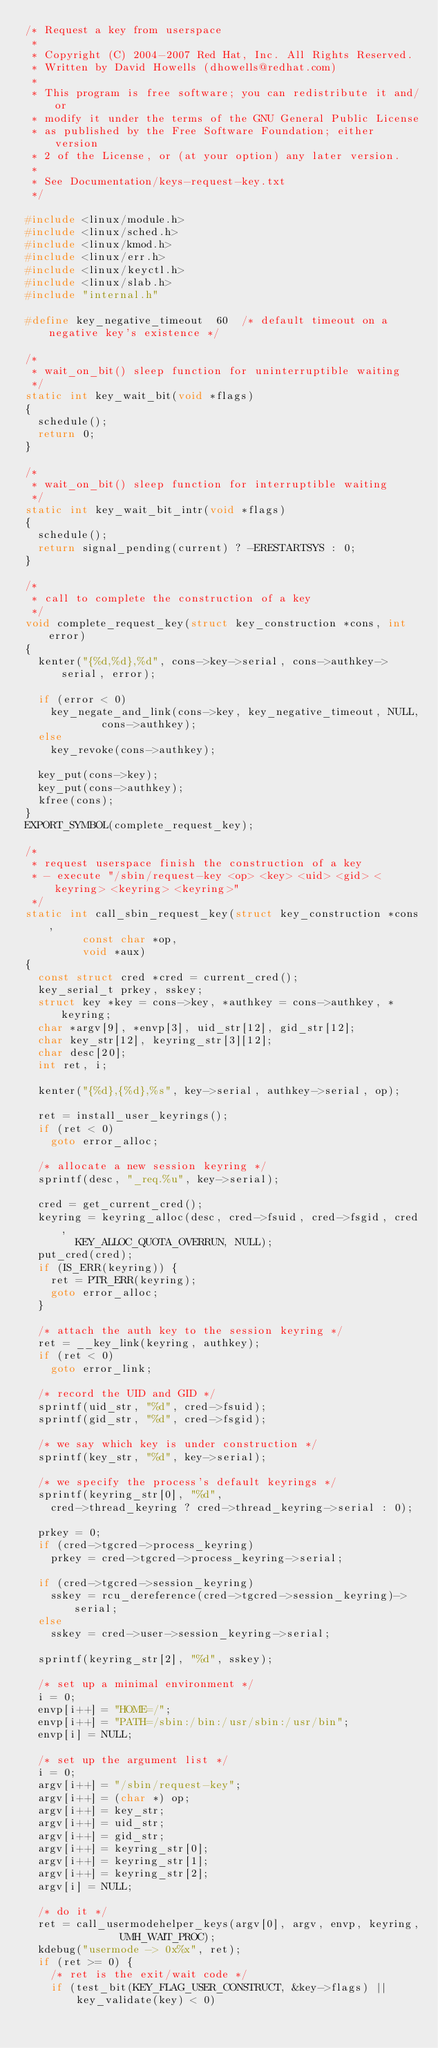Convert code to text. <code><loc_0><loc_0><loc_500><loc_500><_C_>/* Request a key from userspace
 *
 * Copyright (C) 2004-2007 Red Hat, Inc. All Rights Reserved.
 * Written by David Howells (dhowells@redhat.com)
 *
 * This program is free software; you can redistribute it and/or
 * modify it under the terms of the GNU General Public License
 * as published by the Free Software Foundation; either version
 * 2 of the License, or (at your option) any later version.
 *
 * See Documentation/keys-request-key.txt
 */

#include <linux/module.h>
#include <linux/sched.h>
#include <linux/kmod.h>
#include <linux/err.h>
#include <linux/keyctl.h>
#include <linux/slab.h>
#include "internal.h"

#define key_negative_timeout	60	/* default timeout on a negative key's existence */

/*
 * wait_on_bit() sleep function for uninterruptible waiting
 */
static int key_wait_bit(void *flags)
{
	schedule();
	return 0;
}

/*
 * wait_on_bit() sleep function for interruptible waiting
 */
static int key_wait_bit_intr(void *flags)
{
	schedule();
	return signal_pending(current) ? -ERESTARTSYS : 0;
}

/*
 * call to complete the construction of a key
 */
void complete_request_key(struct key_construction *cons, int error)
{
	kenter("{%d,%d},%d", cons->key->serial, cons->authkey->serial, error);

	if (error < 0)
		key_negate_and_link(cons->key, key_negative_timeout, NULL,
				    cons->authkey);
	else
		key_revoke(cons->authkey);

	key_put(cons->key);
	key_put(cons->authkey);
	kfree(cons);
}
EXPORT_SYMBOL(complete_request_key);

/*
 * request userspace finish the construction of a key
 * - execute "/sbin/request-key <op> <key> <uid> <gid> <keyring> <keyring> <keyring>"
 */
static int call_sbin_request_key(struct key_construction *cons,
				 const char *op,
				 void *aux)
{
	const struct cred *cred = current_cred();
	key_serial_t prkey, sskey;
	struct key *key = cons->key, *authkey = cons->authkey, *keyring;
	char *argv[9], *envp[3], uid_str[12], gid_str[12];
	char key_str[12], keyring_str[3][12];
	char desc[20];
	int ret, i;

	kenter("{%d},{%d},%s", key->serial, authkey->serial, op);

	ret = install_user_keyrings();
	if (ret < 0)
		goto error_alloc;

	/* allocate a new session keyring */
	sprintf(desc, "_req.%u", key->serial);

	cred = get_current_cred();
	keyring = keyring_alloc(desc, cred->fsuid, cred->fsgid, cred,
				KEY_ALLOC_QUOTA_OVERRUN, NULL);
	put_cred(cred);
	if (IS_ERR(keyring)) {
		ret = PTR_ERR(keyring);
		goto error_alloc;
	}

	/* attach the auth key to the session keyring */
	ret = __key_link(keyring, authkey);
	if (ret < 0)
		goto error_link;

	/* record the UID and GID */
	sprintf(uid_str, "%d", cred->fsuid);
	sprintf(gid_str, "%d", cred->fsgid);

	/* we say which key is under construction */
	sprintf(key_str, "%d", key->serial);

	/* we specify the process's default keyrings */
	sprintf(keyring_str[0], "%d",
		cred->thread_keyring ? cred->thread_keyring->serial : 0);

	prkey = 0;
	if (cred->tgcred->process_keyring)
		prkey = cred->tgcred->process_keyring->serial;

	if (cred->tgcred->session_keyring)
		sskey = rcu_dereference(cred->tgcred->session_keyring)->serial;
	else
		sskey = cred->user->session_keyring->serial;

	sprintf(keyring_str[2], "%d", sskey);

	/* set up a minimal environment */
	i = 0;
	envp[i++] = "HOME=/";
	envp[i++] = "PATH=/sbin:/bin:/usr/sbin:/usr/bin";
	envp[i] = NULL;

	/* set up the argument list */
	i = 0;
	argv[i++] = "/sbin/request-key";
	argv[i++] = (char *) op;
	argv[i++] = key_str;
	argv[i++] = uid_str;
	argv[i++] = gid_str;
	argv[i++] = keyring_str[0];
	argv[i++] = keyring_str[1];
	argv[i++] = keyring_str[2];
	argv[i] = NULL;

	/* do it */
	ret = call_usermodehelper_keys(argv[0], argv, envp, keyring,
				       UMH_WAIT_PROC);
	kdebug("usermode -> 0x%x", ret);
	if (ret >= 0) {
		/* ret is the exit/wait code */
		if (test_bit(KEY_FLAG_USER_CONSTRUCT, &key->flags) ||
		    key_validate(key) < 0)</code> 